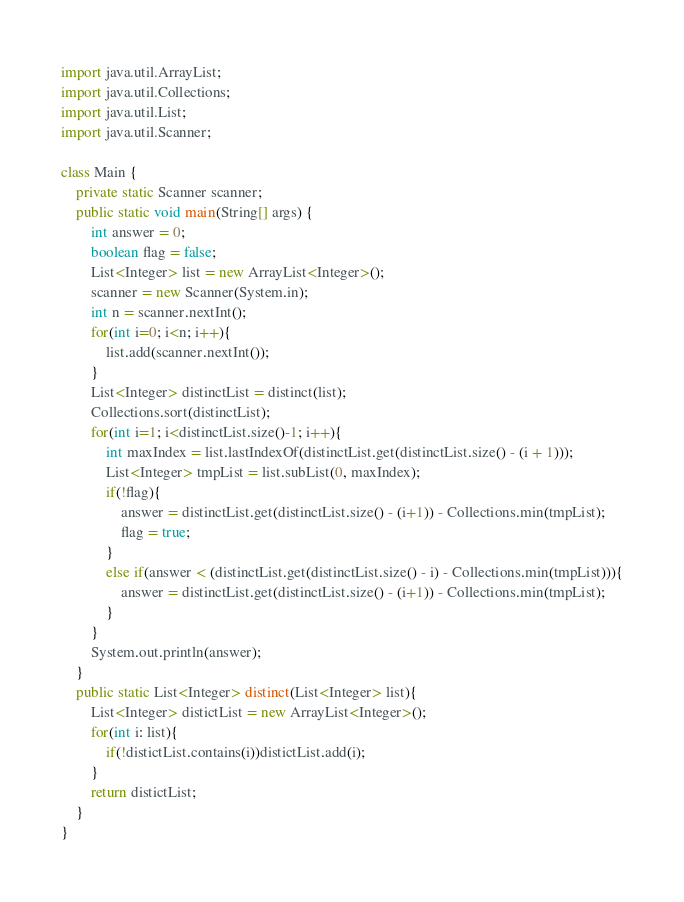Convert code to text. <code><loc_0><loc_0><loc_500><loc_500><_Java_>import java.util.ArrayList;
import java.util.Collections;
import java.util.List;
import java.util.Scanner;

class Main {
	private static Scanner scanner;
	public static void main(String[] args) {
		int answer = 0;
		boolean flag = false;
		List<Integer> list = new ArrayList<Integer>();
		scanner = new Scanner(System.in);
		int n = scanner.nextInt();
		for(int i=0; i<n; i++){
			list.add(scanner.nextInt());
		}
		List<Integer> distinctList = distinct(list);
		Collections.sort(distinctList);
		for(int i=1; i<distinctList.size()-1; i++){
			int maxIndex = list.lastIndexOf(distinctList.get(distinctList.size() - (i + 1)));
			List<Integer> tmpList = list.subList(0, maxIndex);
			if(!flag){
				answer = distinctList.get(distinctList.size() - (i+1)) - Collections.min(tmpList);
				flag = true;
			}
			else if(answer < (distinctList.get(distinctList.size() - i) - Collections.min(tmpList))){
				answer = distinctList.get(distinctList.size() - (i+1)) - Collections.min(tmpList);
			}
		}
		System.out.println(answer);
	}
	public static List<Integer> distinct(List<Integer> list){
		List<Integer> distictList = new ArrayList<Integer>();
		for(int i: list){
			if(!distictList.contains(i))distictList.add(i);
		}
		return distictList;
	}
}</code> 